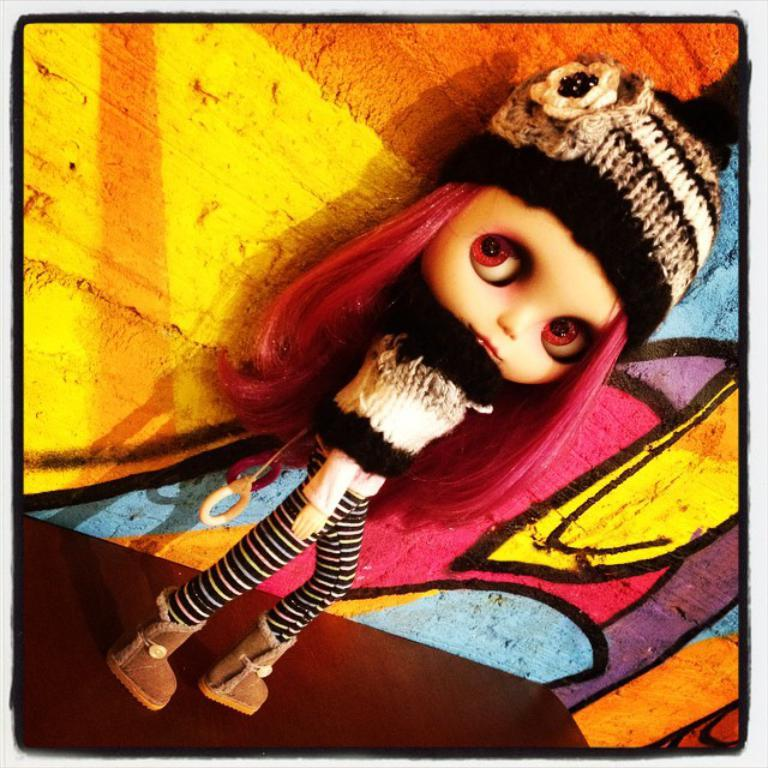What type of editing has been done to the image? The image is edited, but the specific type of editing is not mentioned in the facts. What is placed on the surface in the image? There is a doll on the surface in the image. What can be seen behind the doll in the image? There is a colorful wall behind the doll in the image. What type of salt is sprinkled on the doll in the image? There is no salt present in the image; it features a doll on a surface with a colorful wall behind it. 